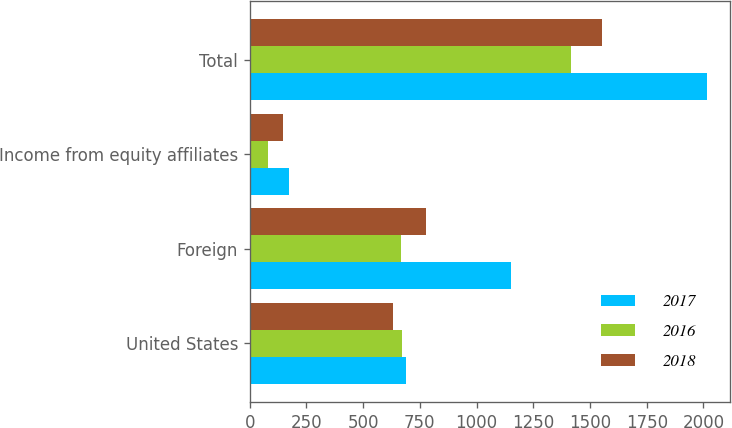Convert chart. <chart><loc_0><loc_0><loc_500><loc_500><stacked_bar_chart><ecel><fcel>United States<fcel>Foreign<fcel>Income from equity affiliates<fcel>Total<nl><fcel>2017<fcel>688.5<fcel>1151.7<fcel>174.8<fcel>2015<nl><fcel>2016<fcel>669.8<fcel>666.2<fcel>80.1<fcel>1416.1<nl><fcel>2018<fcel>631.7<fcel>775.9<fcel>147<fcel>1554.6<nl></chart> 